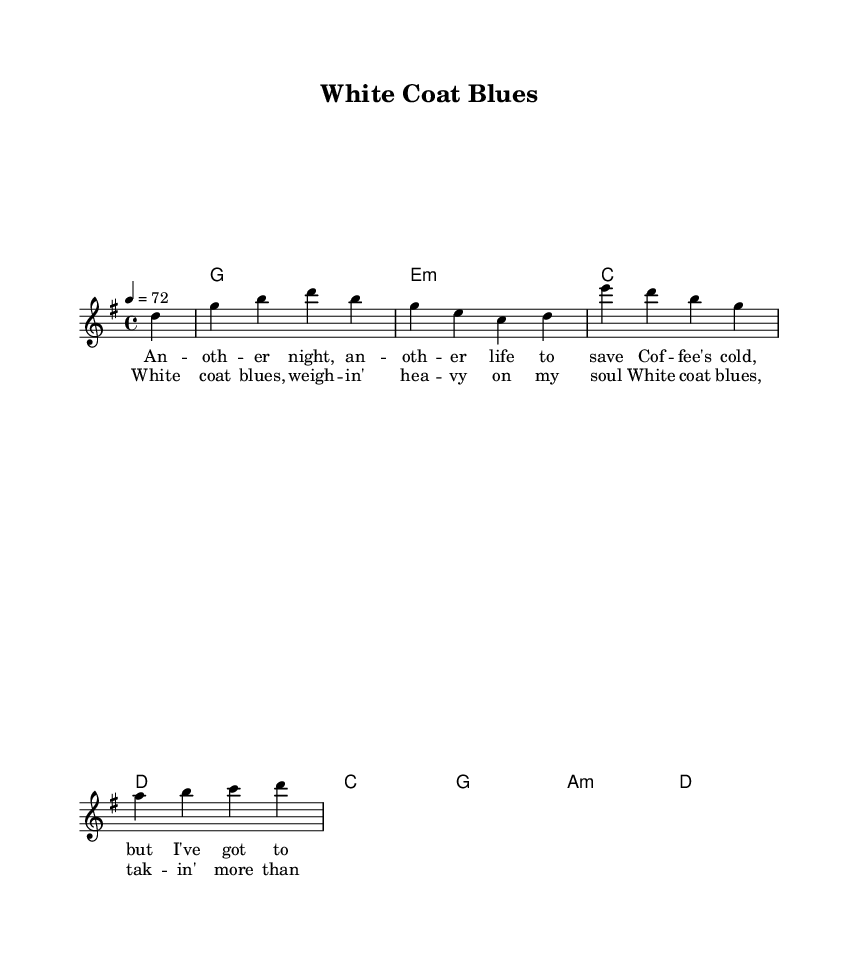What is the key signature of this music? The key signature is G major, which has one sharp (F#). This can be determined by looking at the initial part of the score where the key signature is indicated.
Answer: G major What is the time signature of this music? The time signature is 4/4, which means there are four beats in each measure and the quarter note gets one beat. This is noted at the beginning of the score next to the key signature.
Answer: 4/4 What is the tempo marking for this music? The tempo marking is 72 beats per minute, indicated alongside the time signature. It shows the pace at which the music should be played.
Answer: 72 How many lines are in the melody staff? The melody staff has five lines, which is standard for treble clef notation. This can be observed from the typical layout of the staff in the sheet music.
Answer: 5 How many chords are played in the harmonies section? There are eight chords listed in the harmonies section, including different chord types like major and minor. This is found by counting each chord symbol that appears in the harmonies part.
Answer: 8 What is the first line of the verse lyrics? The first line of the verse lyrics is "An -- oth -- er night, an -- oth -- er life to save". This can be directly seen in the lyrics section corresponding to the melody.
Answer: An -- oth -- er night, an -- oth -- er life to save What is the emotional theme of the song expressed in the chorus? The emotional theme expressed in the chorus relates to the burdens of medical training, specifically noted in the phrase "weigh -- in' hea -- vy on my soul". This reflection on emotional stress is clear in the lyrical content.
Answer: Weigh -- in' hea -- vy on my soul 